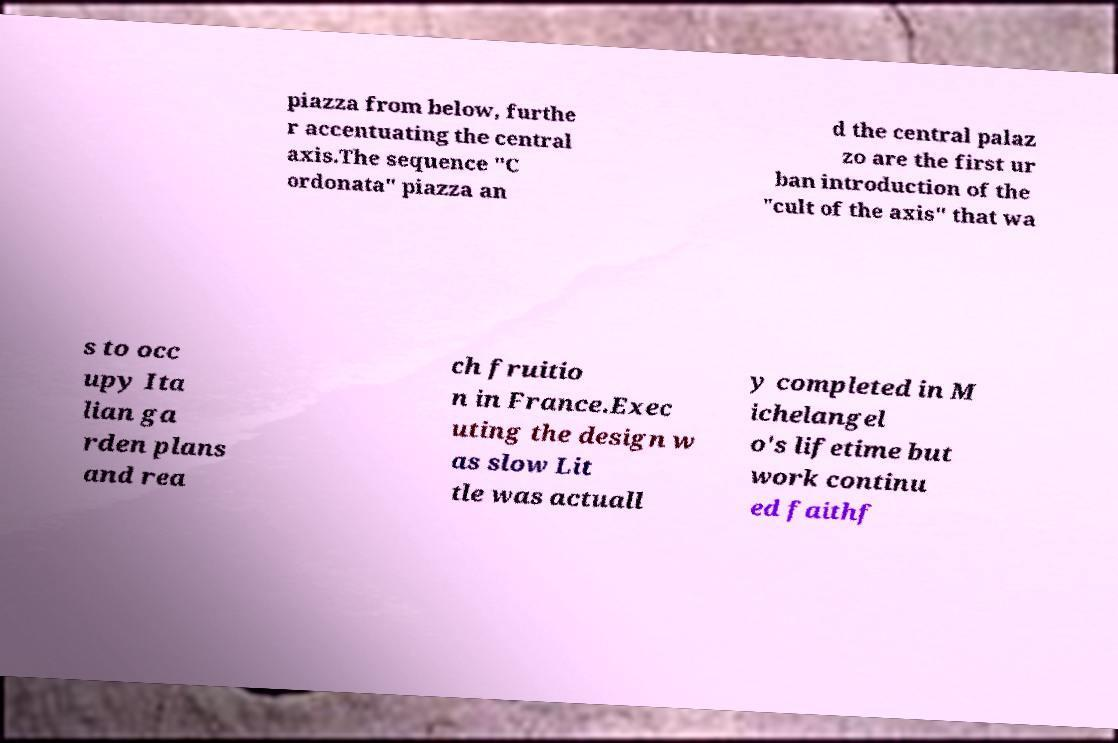Please read and relay the text visible in this image. What does it say? piazza from below, furthe r accentuating the central axis.The sequence "C ordonata" piazza an d the central palaz zo are the first ur ban introduction of the "cult of the axis" that wa s to occ upy Ita lian ga rden plans and rea ch fruitio n in France.Exec uting the design w as slow Lit tle was actuall y completed in M ichelangel o's lifetime but work continu ed faithf 